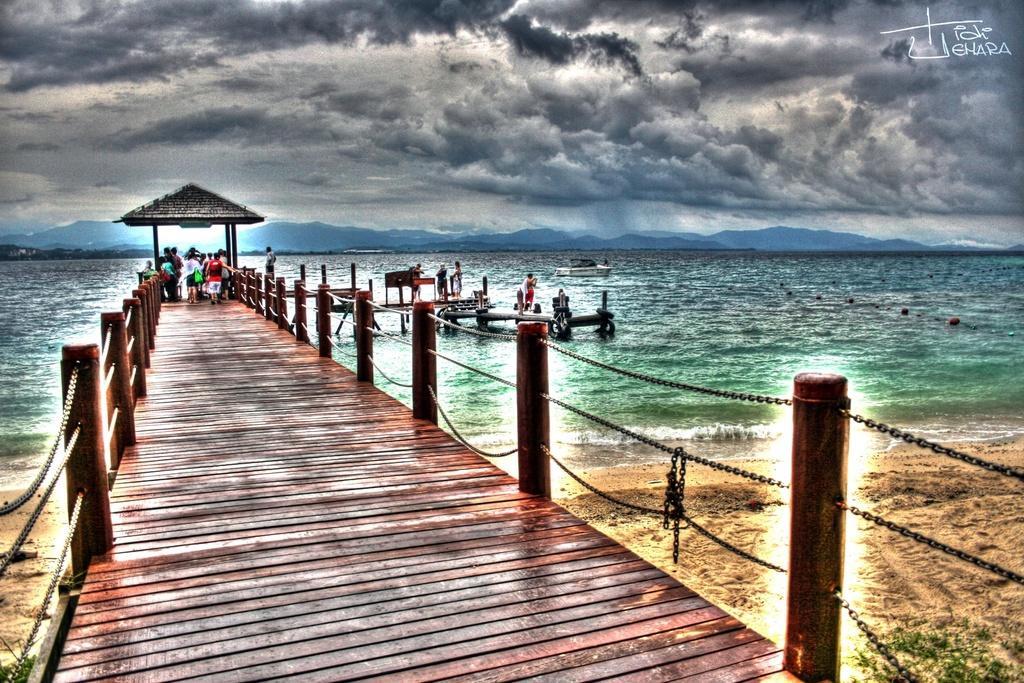Please provide a concise description of this image. In the center of the image there is a boardwalk and we can see people on the boardwalk. On the right we can see people on the boats. In the background there is a sea, hills and sky. 